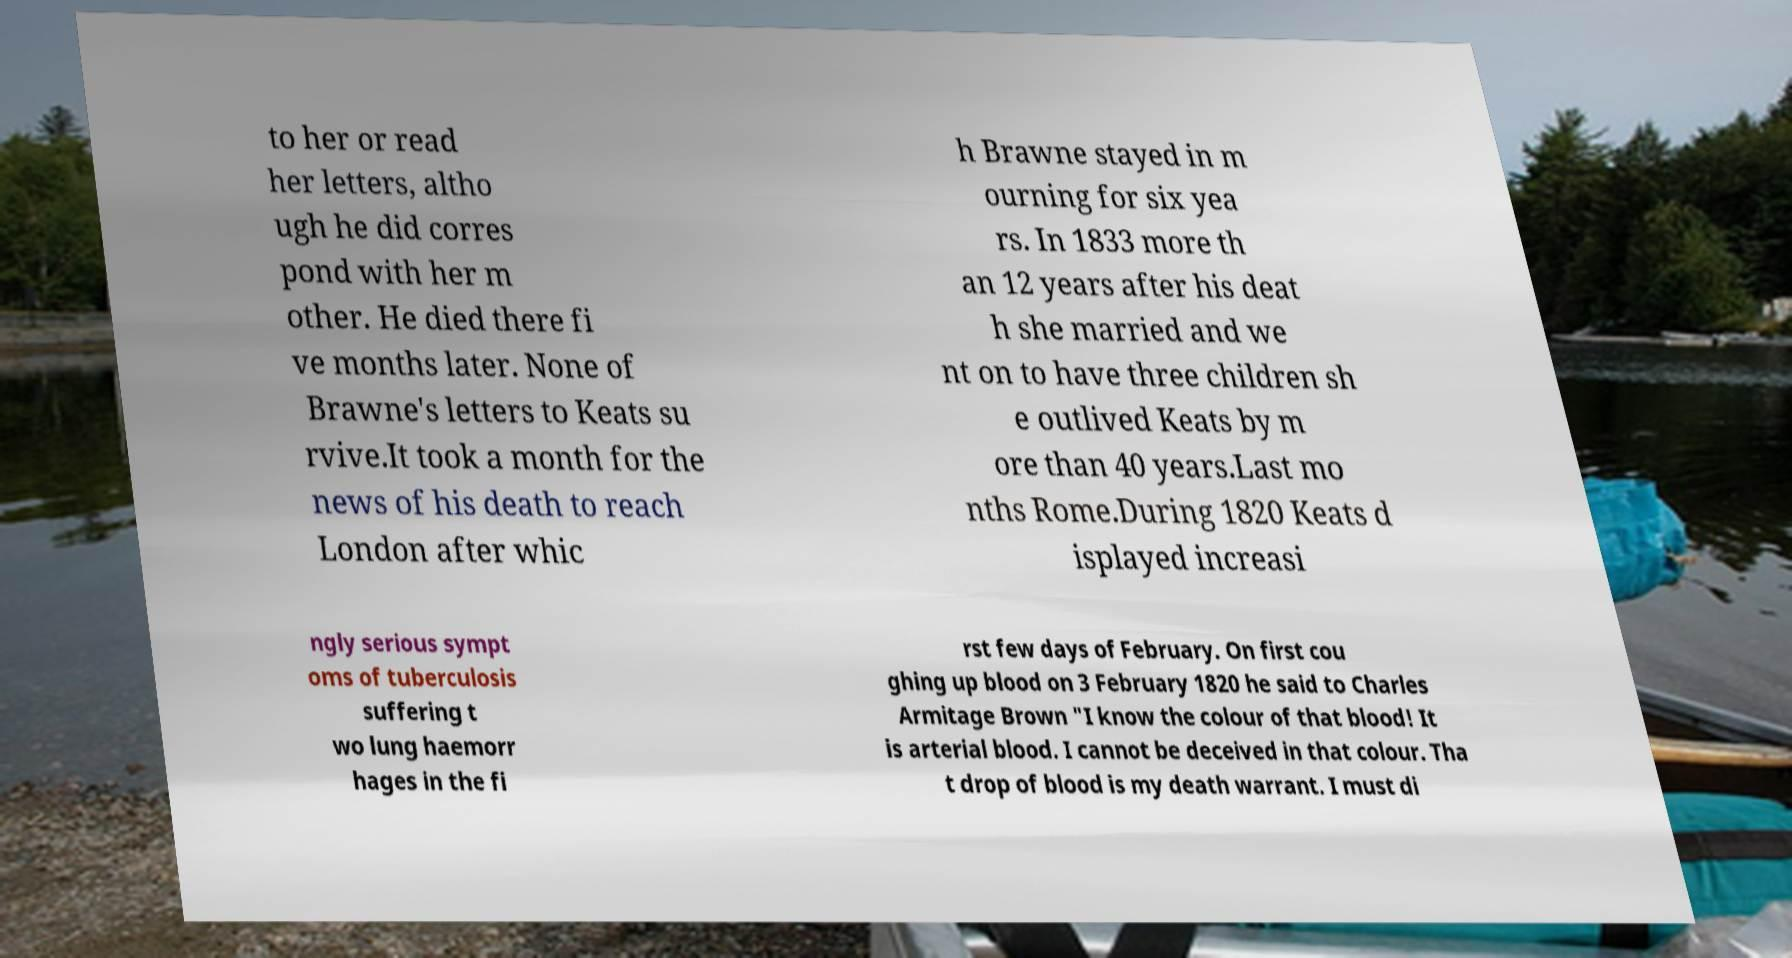There's text embedded in this image that I need extracted. Can you transcribe it verbatim? to her or read her letters, altho ugh he did corres pond with her m other. He died there fi ve months later. None of Brawne's letters to Keats su rvive.It took a month for the news of his death to reach London after whic h Brawne stayed in m ourning for six yea rs. In 1833 more th an 12 years after his deat h she married and we nt on to have three children sh e outlived Keats by m ore than 40 years.Last mo nths Rome.During 1820 Keats d isplayed increasi ngly serious sympt oms of tuberculosis suffering t wo lung haemorr hages in the fi rst few days of February. On first cou ghing up blood on 3 February 1820 he said to Charles Armitage Brown "I know the colour of that blood! It is arterial blood. I cannot be deceived in that colour. Tha t drop of blood is my death warrant. I must di 